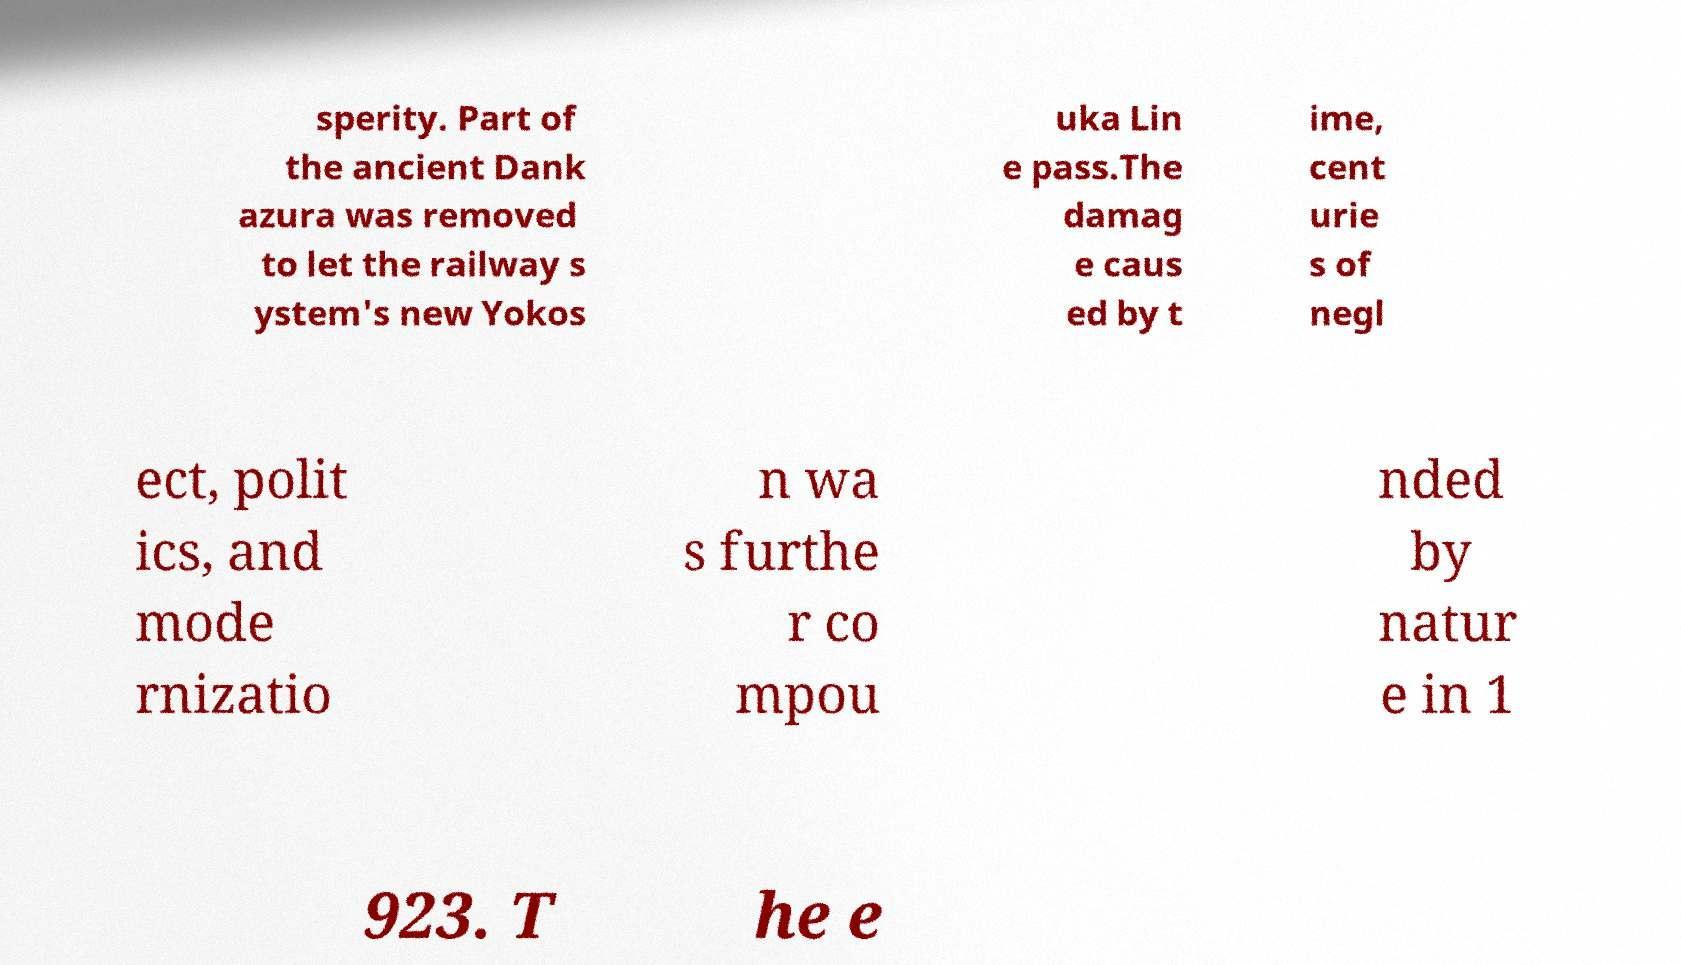What messages or text are displayed in this image? I need them in a readable, typed format. sperity. Part of the ancient Dank azura was removed to let the railway s ystem's new Yokos uka Lin e pass.The damag e caus ed by t ime, cent urie s of negl ect, polit ics, and mode rnizatio n wa s furthe r co mpou nded by natur e in 1 923. T he e 